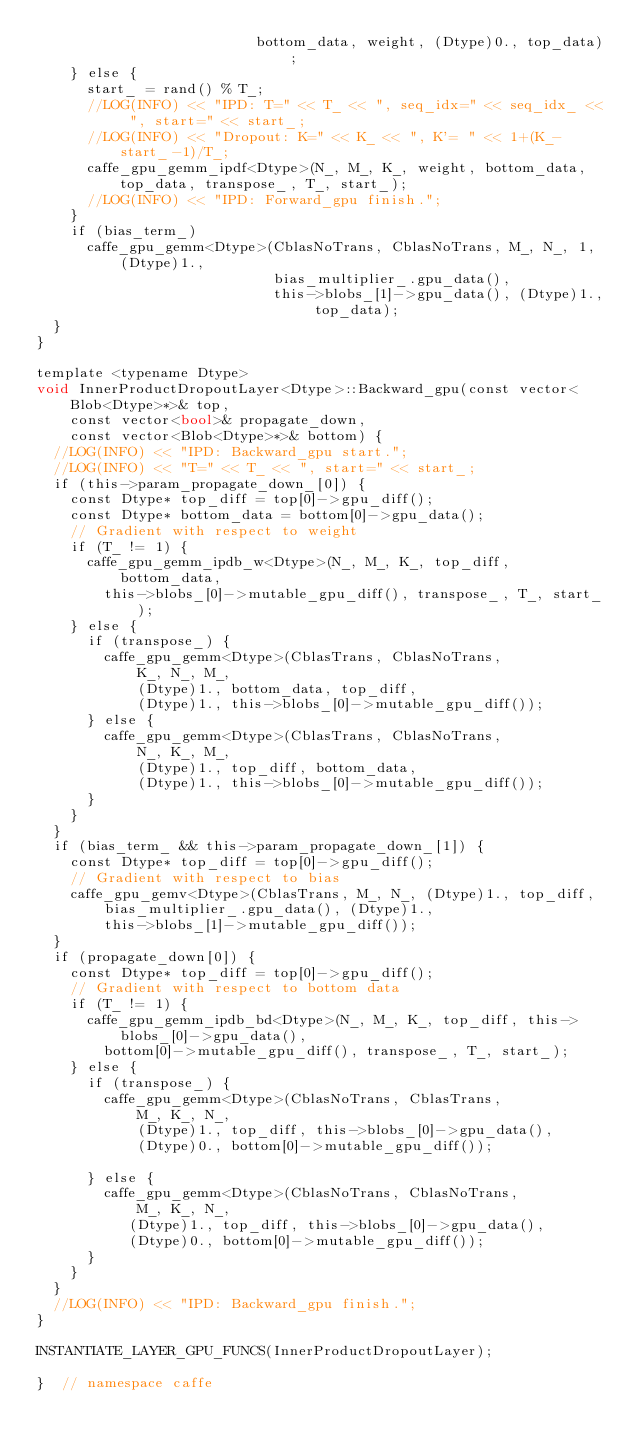<code> <loc_0><loc_0><loc_500><loc_500><_Cuda_>                          bottom_data, weight, (Dtype)0., top_data);
    } else {
      start_ = rand() % T_;
      //LOG(INFO) << "IPD: T=" << T_ << ", seq_idx=" << seq_idx_ << ", start=" << start_;
      //LOG(INFO) << "Dropout: K=" << K_ << ", K'= " << 1+(K_-start_-1)/T_;
      caffe_gpu_gemm_ipdf<Dtype>(N_, M_, K_, weight, bottom_data, top_data, transpose_, T_, start_);
      //LOG(INFO) << "IPD: Forward_gpu finish.";
    }
    if (bias_term_)
      caffe_gpu_gemm<Dtype>(CblasNoTrans, CblasNoTrans, M_, N_, 1, (Dtype)1.,
                            bias_multiplier_.gpu_data(),
                            this->blobs_[1]->gpu_data(), (Dtype)1., top_data);
  }
}

template <typename Dtype>
void InnerProductDropoutLayer<Dtype>::Backward_gpu(const vector<Blob<Dtype>*>& top,
    const vector<bool>& propagate_down,
    const vector<Blob<Dtype>*>& bottom) {
  //LOG(INFO) << "IPD: Backward_gpu start.";
  //LOG(INFO) << "T=" << T_ << ", start=" << start_;
  if (this->param_propagate_down_[0]) {
    const Dtype* top_diff = top[0]->gpu_diff();
    const Dtype* bottom_data = bottom[0]->gpu_data();
    // Gradient with respect to weight
    if (T_ != 1) {
      caffe_gpu_gemm_ipdb_w<Dtype>(N_, M_, K_, top_diff, bottom_data, 
        this->blobs_[0]->mutable_gpu_diff(), transpose_, T_, start_);
    } else {
      if (transpose_) {
        caffe_gpu_gemm<Dtype>(CblasTrans, CblasNoTrans,
            K_, N_, M_,
            (Dtype)1., bottom_data, top_diff,
            (Dtype)1., this->blobs_[0]->mutable_gpu_diff());
      } else {
        caffe_gpu_gemm<Dtype>(CblasTrans, CblasNoTrans,
            N_, K_, M_,
            (Dtype)1., top_diff, bottom_data,
            (Dtype)1., this->blobs_[0]->mutable_gpu_diff());
      }
    }
  }
  if (bias_term_ && this->param_propagate_down_[1]) {
    const Dtype* top_diff = top[0]->gpu_diff();
    // Gradient with respect to bias
    caffe_gpu_gemv<Dtype>(CblasTrans, M_, N_, (Dtype)1., top_diff,
        bias_multiplier_.gpu_data(), (Dtype)1.,
        this->blobs_[1]->mutable_gpu_diff());
  }
  if (propagate_down[0]) {
    const Dtype* top_diff = top[0]->gpu_diff();
    // Gradient with respect to bottom data
    if (T_ != 1) {
      caffe_gpu_gemm_ipdb_bd<Dtype>(N_, M_, K_, top_diff, this->blobs_[0]->gpu_data(), 
        bottom[0]->mutable_gpu_diff(), transpose_, T_, start_);
    } else {
      if (transpose_) {
        caffe_gpu_gemm<Dtype>(CblasNoTrans, CblasTrans,
            M_, K_, N_,
            (Dtype)1., top_diff, this->blobs_[0]->gpu_data(),
            (Dtype)0., bottom[0]->mutable_gpu_diff());

      } else {
        caffe_gpu_gemm<Dtype>(CblasNoTrans, CblasNoTrans,
            M_, K_, N_,
           (Dtype)1., top_diff, this->blobs_[0]->gpu_data(),
           (Dtype)0., bottom[0]->mutable_gpu_diff());
      }
    }
  }
  //LOG(INFO) << "IPD: Backward_gpu finish.";
}

INSTANTIATE_LAYER_GPU_FUNCS(InnerProductDropoutLayer);

}  // namespace caffe

</code> 